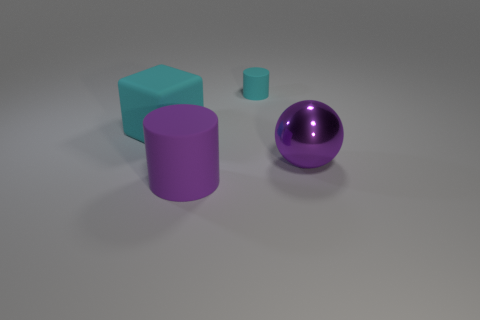Add 2 tiny green metallic blocks. How many objects exist? 6 Subtract all blocks. How many objects are left? 3 Subtract 0 green cylinders. How many objects are left? 4 Subtract all large brown matte things. Subtract all purple cylinders. How many objects are left? 3 Add 3 cyan matte blocks. How many cyan matte blocks are left? 4 Add 1 gray cylinders. How many gray cylinders exist? 1 